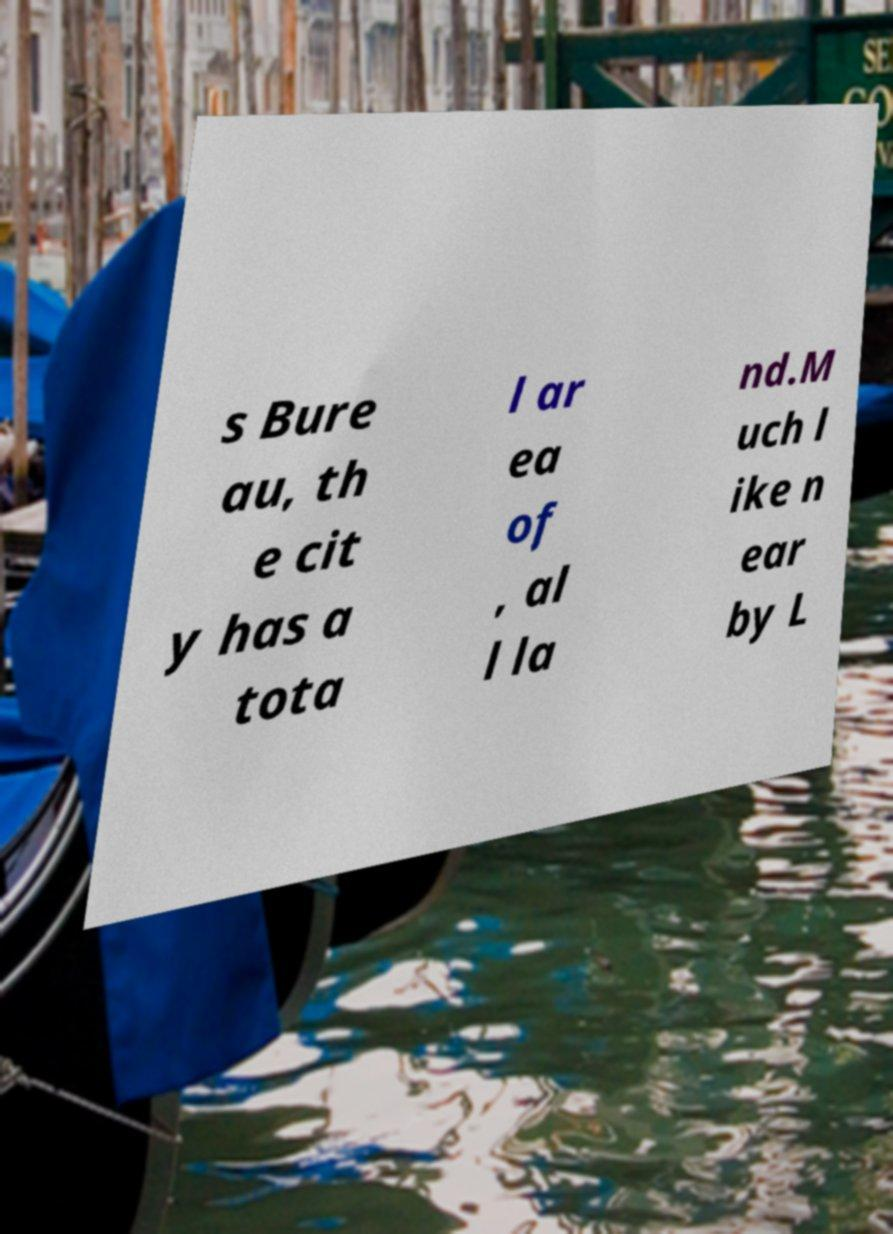Could you extract and type out the text from this image? s Bure au, th e cit y has a tota l ar ea of , al l la nd.M uch l ike n ear by L 